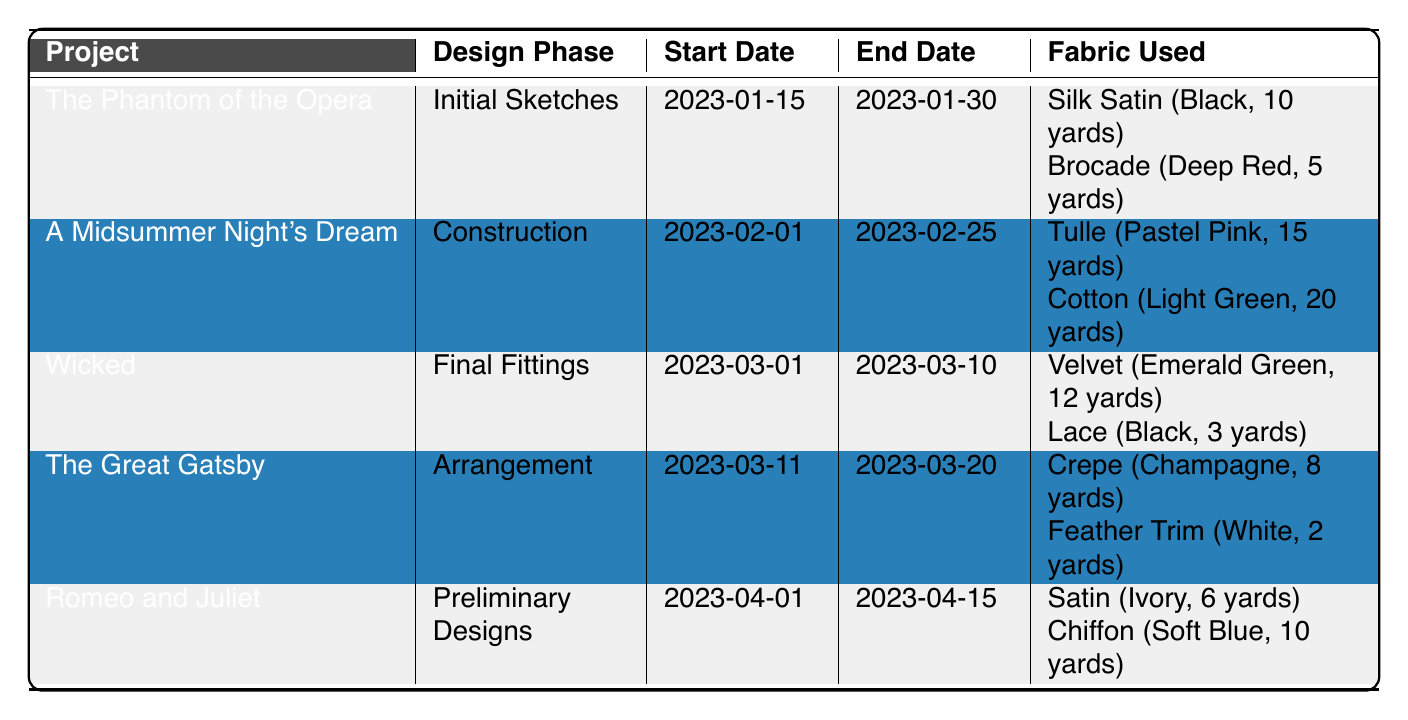What is the project name associated with the design phase "Construction"? To find the project name for this specific design phase, scan the "Design Phase" column to locate "Construction", which is found in the row corresponding to "A Midsummer Night's Dream". The "Project" column in the same row reveals the project name.
Answer: A Midsummer Night's Dream Which fabric is used in "The Phantom of the Opera" project? Looking at the row for "The Phantom of the Opera" under the "Fabric Used" column, it lists "Silk Satin" (Black, 10 yards) and "Brocade" (Deep Red, 5 yards). Both fabric names are given in the same row.
Answer: Silk Satin and Brocade Does "Wicked" use any black fabric? To answer, check the "Fabric Used" section for the project "Wicked" and see if any fabric listed has Black as a color. The row for "Wicked" shows "Lace" (Black, 3 yards), indicating the presence of black fabric.
Answer: Yes What is the total quantity of fabric used in "A Midsummer Night's Dream"? To calculate the total quantity, examine the "Fabric Used" entry for "A Midsummer Night's Dream". It lists "Tulle" (15 yards) and "Cotton" (20 yards). Adding these quantities gives 15 + 20 = 35 yards.
Answer: 35 yards Which project has the longest design phase duration? Determine the duration of each design phase by subtracting the start date from the end date for each project. The durations are: 15 days (The Phantom of the Opera), 24 days (A Midsummer Night's Dream), 10 days (Wicked), 9 days (The Great Gatsby), and 15 days (Romeo and Juliet). Comparing these durations shows that "A Midsummer Night's Dream" has the longest duration of 24 days.
Answer: A Midsummer Night's Dream How many yards of fabric did "Romeo and Juliet" use in total? Review the "Fabric Used" section for "Romeo and Juliet". It shows "Satin" (Ivory, 6 yards) and "Chiffon" (Soft Blue, 10 yards). Adding these amounts gives 6 + 10 = 16 yards in total.
Answer: 16 yards Is there a project that uses Velvet fabric? Check the "Fabric Used" for each project and identify if "Velvet" is present. It is listed in the row for "Wicked", confirming its use.
Answer: Yes What is the color of the fabric used in "The Great Gatsby"? The row for "The Great Gatsby" contains information about the fabric colors under the "Fabric Used" column. The colors listed are "Champagne" and "White".
Answer: Champagne and White 